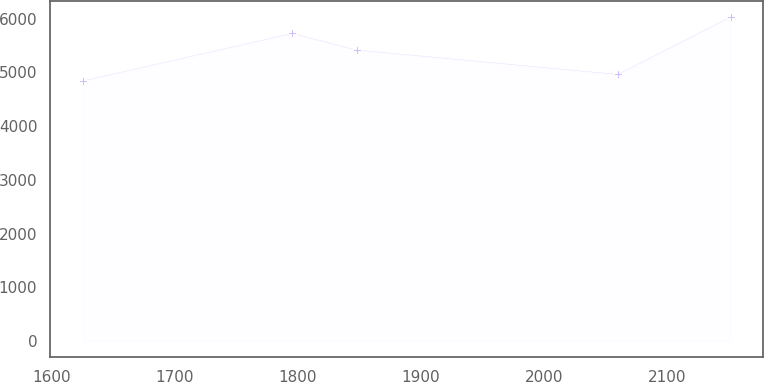Convert chart to OTSL. <chart><loc_0><loc_0><loc_500><loc_500><line_chart><ecel><fcel>Unnamed: 1<nl><fcel>1625.06<fcel>4842.61<nl><fcel>1795.29<fcel>5724.52<nl><fcel>1847.99<fcel>5415.64<nl><fcel>2060.26<fcel>4961.95<nl><fcel>2152.1<fcel>6035.99<nl></chart> 